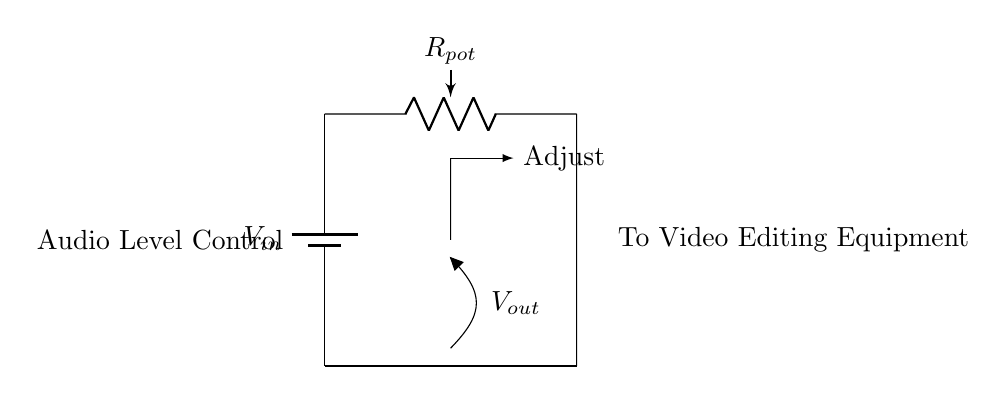What is the input voltage labeled in the circuit? The input voltage is represented as V_in in the diagram, indicating where the power supply connects. It is the voltage that will be modified by the potentiometer.
Answer: V_in What type of component is used for audio level control? The component used for audio level control is labeled as R_pot, which signifies the potentiometer. A potentiometer can adjust voltage levels through its variable resistance.
Answer: Potentiometer What is the output voltage labeled in the circuit? The output voltage is indicated as V_out in the circuit diagram. It is the voltage that emerges from the wiper of the potentiometer, which will be sent to the video editing equipment.
Answer: V_out How many terminals does the potentiometer have? A potentiometer typically has three terminals: two for the ends of the resistive element and one for the wiper, which varies the voltage. This can be inferred from its basic design.
Answer: Three What happens when you adjust the potentiometer? Adjusting the potentiometer changes the resistance in the circuit, allowing for the modification of V_out. The wiper position alters the ratio of voltages divided through R_pot, affecting the audio levels.
Answer: Changes audio levels What is the relationship between the input and output voltage in this divider? The output voltage (V_out) is a fraction of the input voltage (V_in) based on the resistance values of the potentiometer, following the voltage divider rule, V_out = (R2 / (R1 + R2)) * V_in. Here, the adjustment of R_pot modifies this relationship.
Answer: Fraction of V_in What role does the wiper play in the circuit? The wiper enables variable output voltage by changing the resistance ratio across the potentiometer, effectively adjusting the voltage sent to the audio level output. This plays a crucial role in fine-tuning audio signals.
Answer: Variable output voltage 